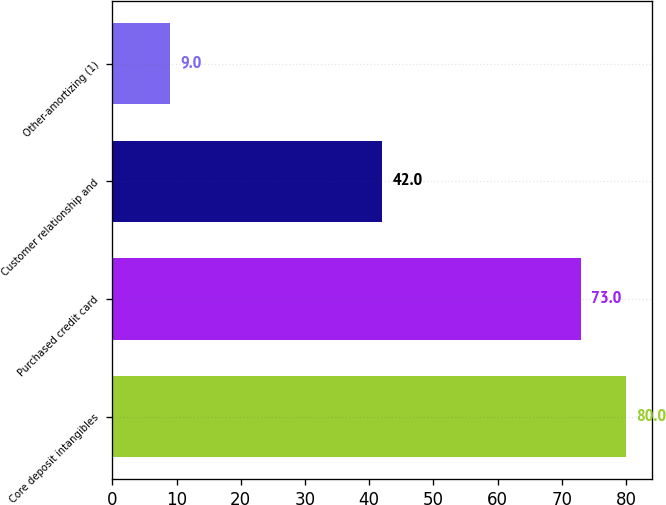Convert chart to OTSL. <chart><loc_0><loc_0><loc_500><loc_500><bar_chart><fcel>Core deposit intangibles<fcel>Purchased credit card<fcel>Customer relationship and<fcel>Other-amortizing (1)<nl><fcel>80<fcel>73<fcel>42<fcel>9<nl></chart> 